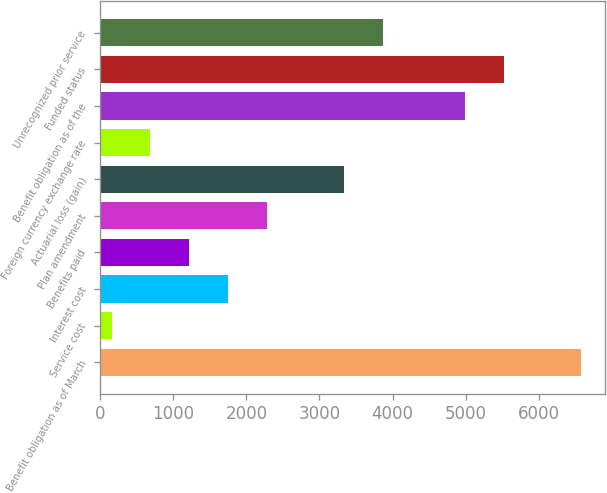Convert chart to OTSL. <chart><loc_0><loc_0><loc_500><loc_500><bar_chart><fcel>Benefit obligation as of March<fcel>Service cost<fcel>Interest cost<fcel>Benefits paid<fcel>Plan amendment<fcel>Actuarial loss (gain)<fcel>Foreign currency exchange rate<fcel>Benefit obligation as of the<fcel>Funded status<fcel>Unrecognized prior service<nl><fcel>6579.6<fcel>158<fcel>1748.6<fcel>1218.4<fcel>2278.8<fcel>3339.2<fcel>688.2<fcel>4989<fcel>5519.2<fcel>3869.4<nl></chart> 